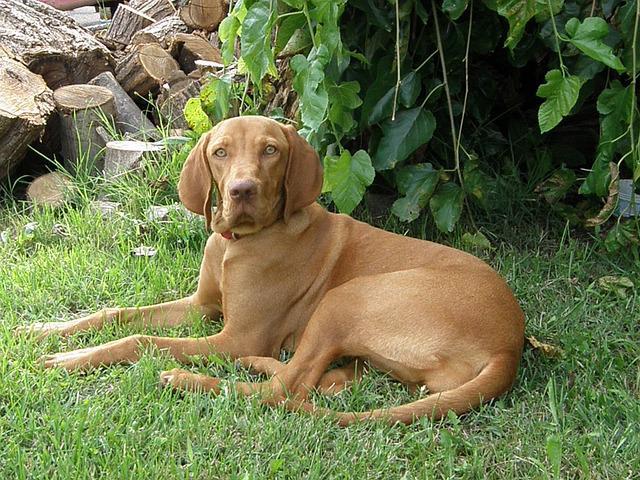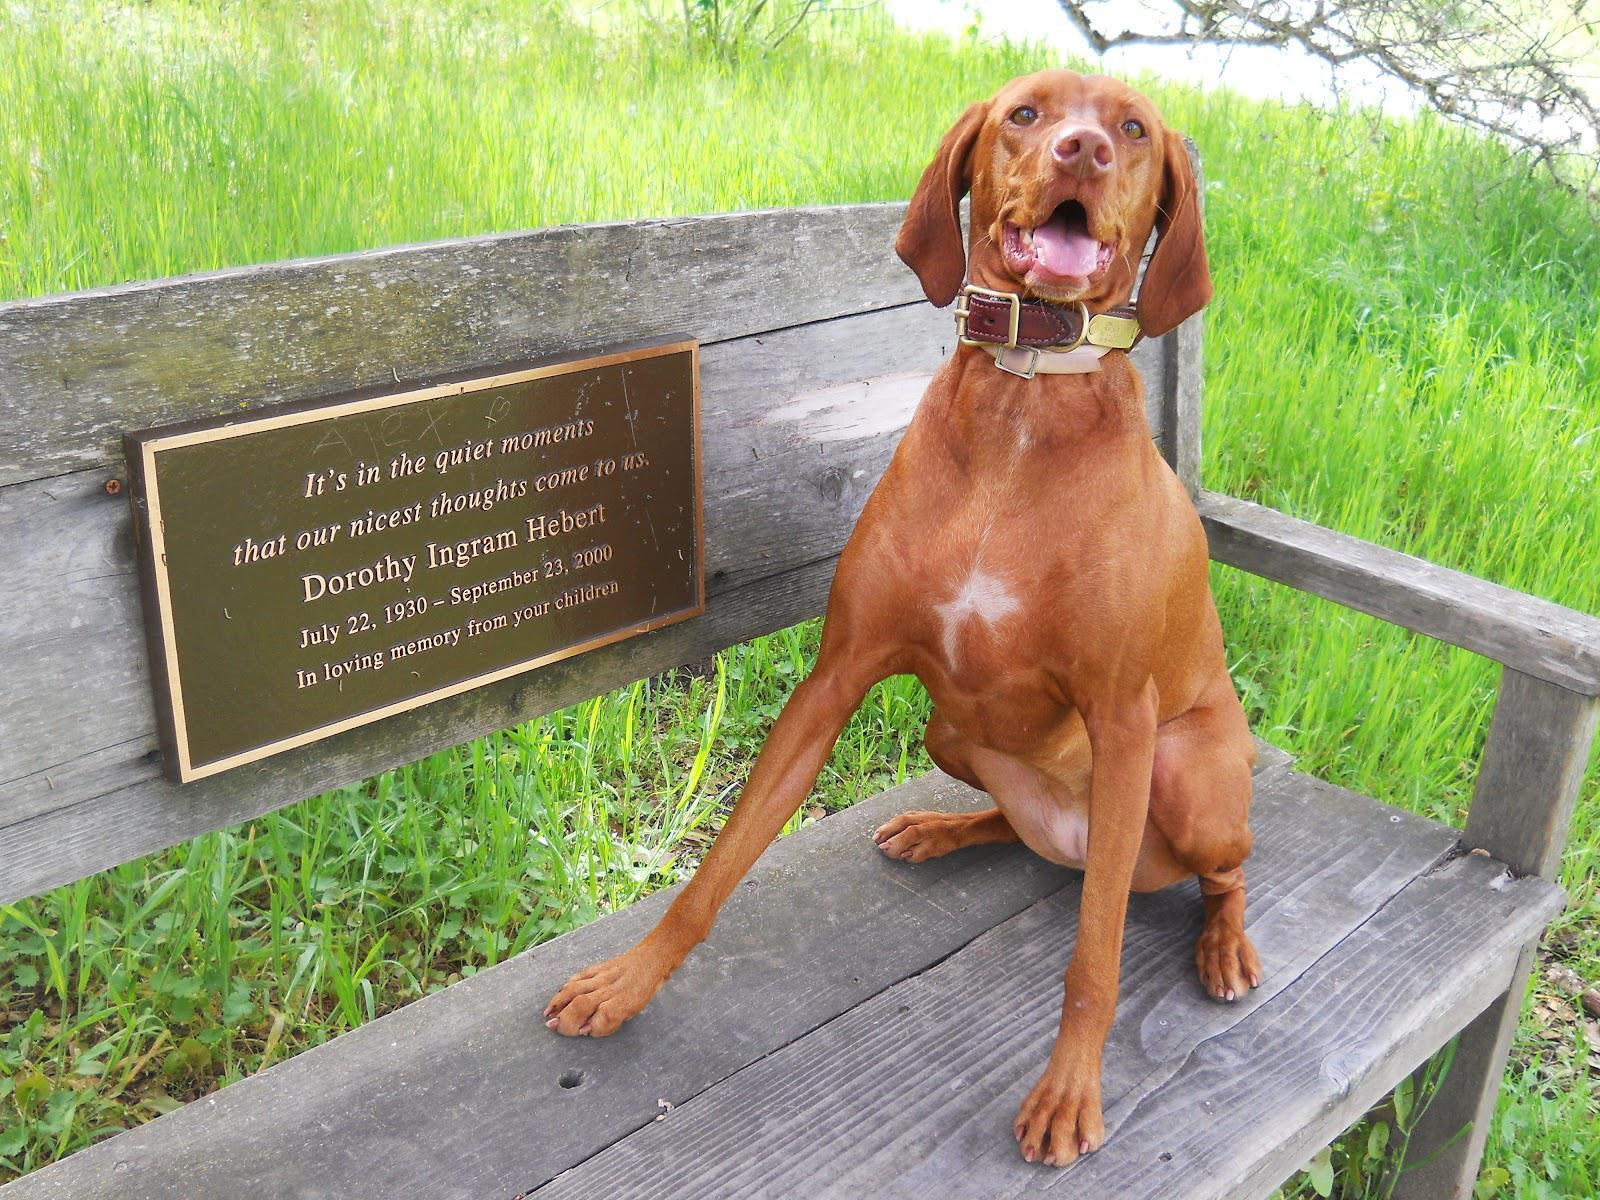The first image is the image on the left, the second image is the image on the right. For the images shown, is this caption "In one of the images, there is a brown dog that is lying in the grass." true? Answer yes or no. Yes. 